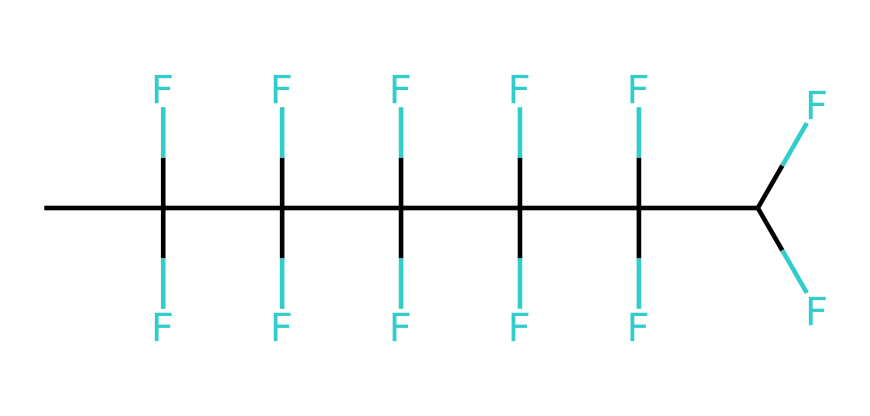What is the molecular formula represented by this SMILES? The SMILES notation indicates the presence of carbon (C) and fluorine (F) atoms. By counting the number of carbon atoms and fluorine atoms from the structure, we find there are 6 carbon atoms and 18 fluorine atoms. Therefore, the molecular formula is C6F18.
Answer: C6F18 How many carbon atoms are in this molecule? The SMILES is analyzed by identifying each carbon atom represented by "C" in the structure. There are a total of 6 carbon atoms present in the chemical structure.
Answer: 6 What is the total number of fluorine atoms in this compound? To determine the number of fluorine atoms, we count how many times "F" appears in the SMILES representation. In this structure, "F" occurs 18 times, corresponding to 18 fluorine atoms.
Answer: 18 Does this polymer contain any hydrogen atoms? In the SMILES structure, there are no "H" atoms explicitly listed or implied by the tetravalent nature of carbon. The presence of multiple fluorine atoms, which fully saturate the bonding sites, indicates that there are no hydrogen atoms in this chemical.
Answer: no What type of polymer does this structure represent? Given the high number of fluorine substitutions on a carbon backbone, this structure is indicative of a fluoropolymer, which is known for chemical resistance and low surface energy properties.
Answer: fluoropolymer What properties are likely enhanced due to the presence of fluorine in this polymer? The presence of fluorine in polymers typically enhances properties such as chemical resistance, thermal stability, and reduced surface friction. This is due to the electronegative nature of fluorine and its tendency to stabilize the polymer structure.
Answer: chemical resistance What is the significance of fluorine in medical device coatings? Fluorine contributes to biocompatibility and reduces protein adsorption due to its low surface energy, making it significant for improving the performance of medical device coatings.
Answer: biocompatibility 